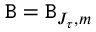<formula> <loc_0><loc_0><loc_500><loc_500>B = B _ { J _ { \tau } , m }</formula> 